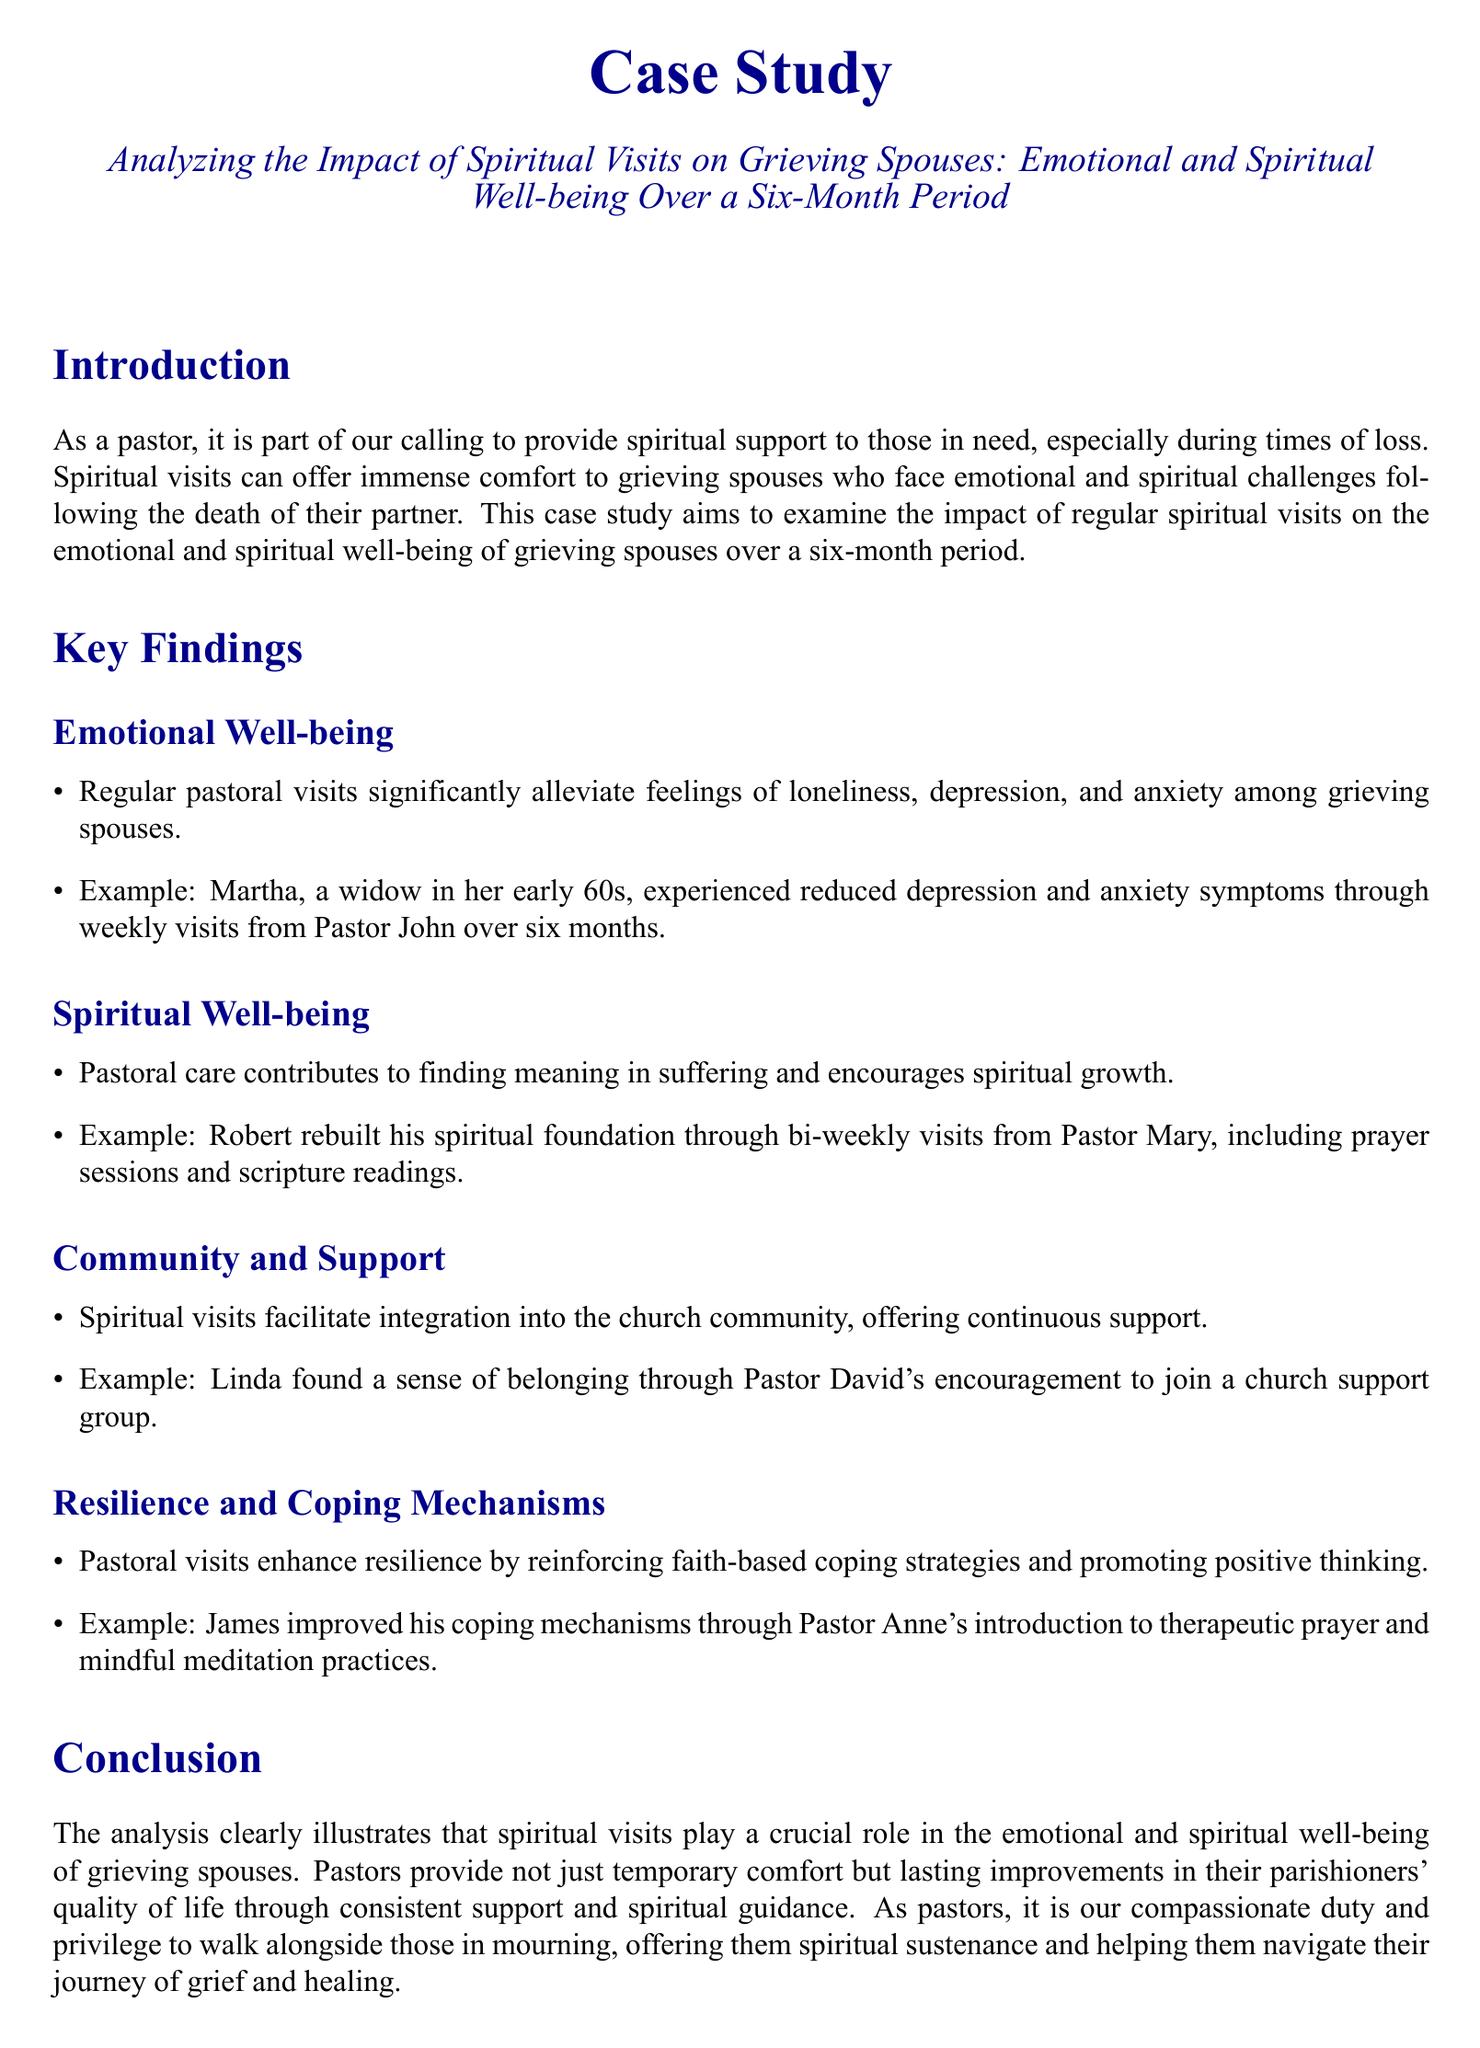what is the title of the case study? The title is found in the center at the beginning of the document and reads "Analyzing the Impact of Spiritual Visits on Grieving Spouses: Emotional and Spiritual Well-being Over a Six-Month Period".
Answer: Analyzing the Impact of Spiritual Visits on Grieving Spouses: Emotional and Spiritual Well-being Over a Six-Month Period who experienced reduced depression and anxiety symptoms? The name of the individual who experienced reduced depression and anxiety symptoms is mentioned as an example under emotional well-being.
Answer: Martha what is a benefit of regular pastoral visits? The benefits are summarized in the key findings section under emotional well-being, where it states regular visits significantly alleviate feelings of loneliness, depression, and anxiety.
Answer: Alleviating feelings of loneliness, depression, and anxiety how often did Robert receive visits from Pastor Mary? The frequency of Robert's visits is specified in the spiritual well-being section as bi-weekly visits from Pastor Mary.
Answer: Bi-weekly which coping mechanisms improved for James? The specific coping mechanisms are mentioned in the resilience and coping mechanisms section involving therapy and meditation practices introduced by Pastor Anne.
Answer: Therapeutic prayer and mindful meditation what is a notable impact on community integration? The impact is highlighted in the community and support section, noting that spiritual visits facilitate integration into the church community.
Answer: Integration into the church community how long was the period analyzed in this case study? The duration of the analysis is noted in the introduction, explicitly stating the timeframe is six months.
Answer: Six months what role do spiritual visits play according to the conclusion? The conclusion emphasizes the essential role of spiritual visits in the emotional and spiritual well-being of grieving spouses.
Answer: Crucial role 